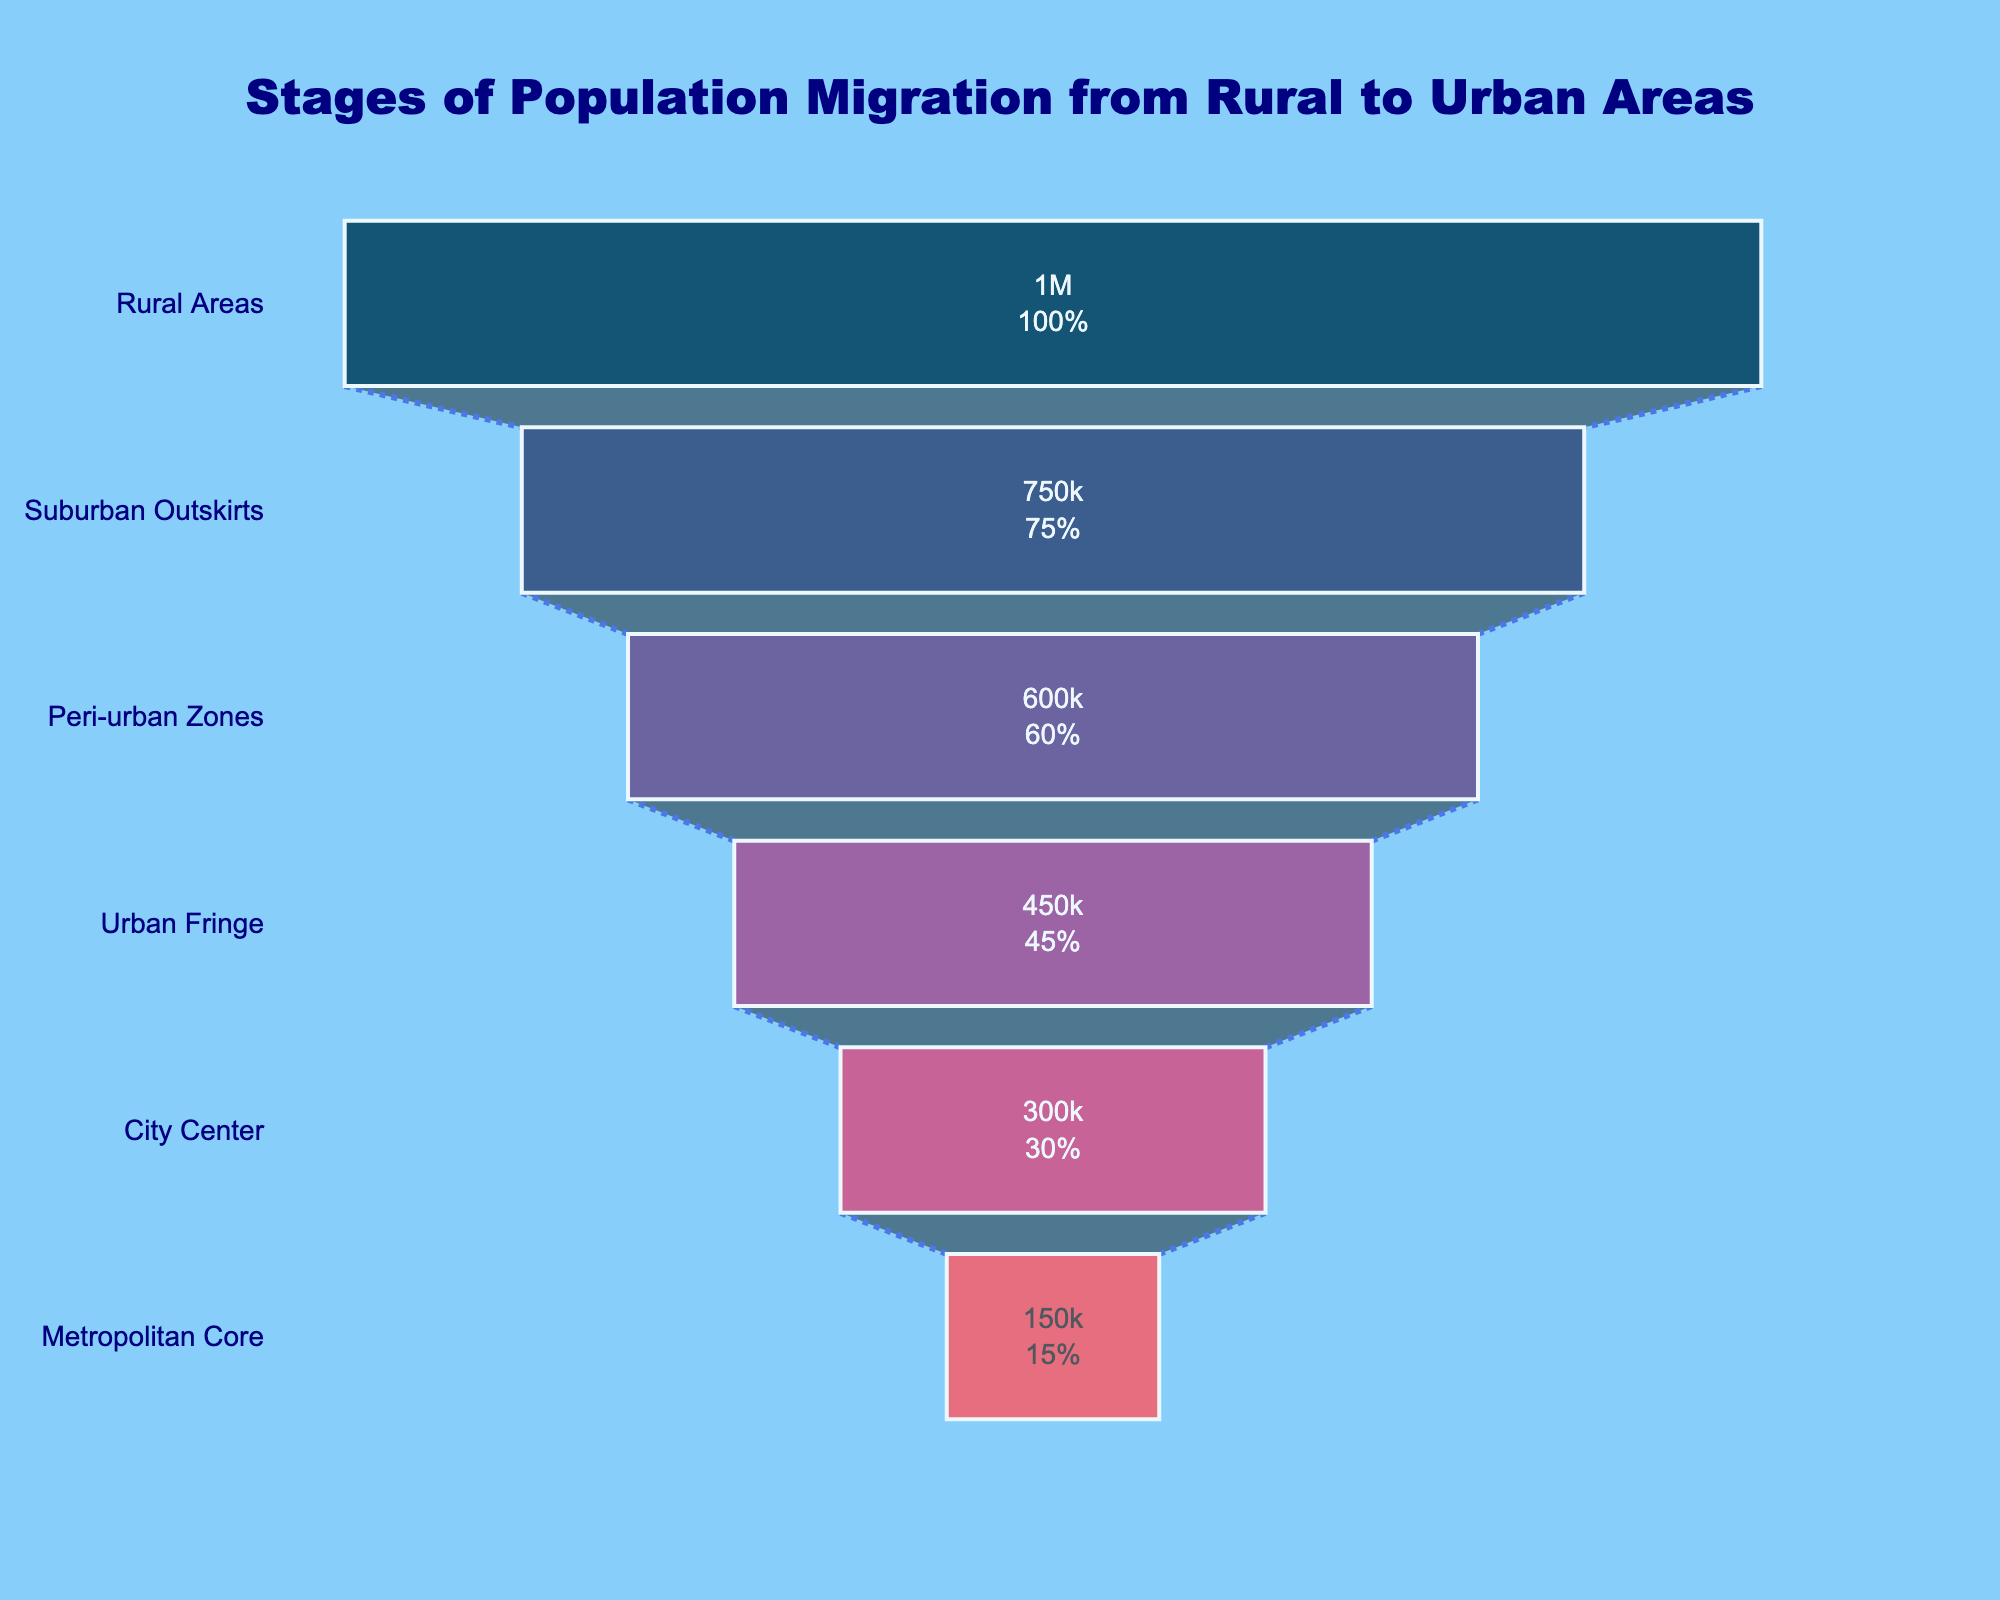What is the total population at the Rural Areas stage? The funnel chart shows the population at the rural areas stage as 1,000,000. You can see this value represented in the top funnel section.
Answer: 1,000,000 What is the difference in population between the Urban Fringe and the Metropolitan Core stages? The population at the Urban Fringe stage is 450,000, and at the Metropolitan Core stage, it's 150,000. The difference is 450,000 - 150,000 = 300,000.
Answer: 300,000 Which stage has the second smallest population? Looking at the funnel chart, the second smallest population is at the City Center stage with 300,000 people.
Answer: City Center What percentage of the total population does the Suburban Outskirts stage represent? The population at the Suburban Outskirts stage is 750,000 out of a total initial population of 1,000,000. The percentage is (750,000 / 1,000,000) * 100 = 75%.
Answer: 75% How many stages are there in the population migration funnel chart? The funnel chart shows six stages of population migration, namely Rural Areas, Suburban Outskirts, Peri-urban Zones, Urban Fringe, City Center, and Metropolitan Core.
Answer: six Which stage experiences the largest drop in population from the previous stage? The drop from Urban Fringe (450,000) to City Center (300,000) is 150,000, and from City Center (300,000) to Metropolitan Core (150,000) is also 150,000. However, the value remains the same for these two comparisons, so the largest single drop is from Urban Fringe to City Center (150,000) or from City Center to Metropolitan Core (150,000).
Answer: Urban Fringe to City Center or City Center to Metropolitan Core What is the cumulative population for the Suburban Outskirts and Peri-urban Zones stages? The population at the Suburban Outskirts stage is 750,000, and at the Peri-urban Zones stage, it's 600,000. Their sum is 750,000 + 600,000 = 1,350,000.
Answer: 1,350,000 What is the median population value among all the stages? To find the median, first list the populations in ascending order: 150,000, 300,000, 450,000, 600,000, 750,000, 1,000,000. Since there are six values, the median is the average of the 3rd and 4th values. Hence, (450,000 + 600,000) / 2 = 525,000.
Answer: 525,000 By what percentage does the population decrease from the Suburban Outskirts stage to the Metropolitan Core stage? The population decreases from 750,000 to 150,000. The decrease is (750,000 - 150,000) / 750,000 * 100 = 80%.
Answer: 80% What distinguishes a funnel chart from other types of charts in terms of visual representation? A funnel chart is specifically designed to show the progressive reduction of data as it passes through different stages, represented by tapered sections of varying widths. The width of each section indicates the population size at each stage.
Answer: Progressive reduction through stages with varying widths 